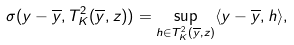Convert formula to latex. <formula><loc_0><loc_0><loc_500><loc_500>\sigma ( y - \overline { y } , T ^ { 2 } _ { K } ( \overline { y } , z ) ) = \sup _ { h \in T ^ { 2 } _ { K } ( \overline { y } , z ) } \langle y - \overline { y } , h \rangle ,</formula> 